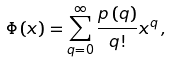<formula> <loc_0><loc_0><loc_500><loc_500>\Phi \left ( x \right ) = \sum _ { q = 0 } ^ { \infty } \frac { p \left ( q \right ) } { q ! } x ^ { q } \, ,</formula> 